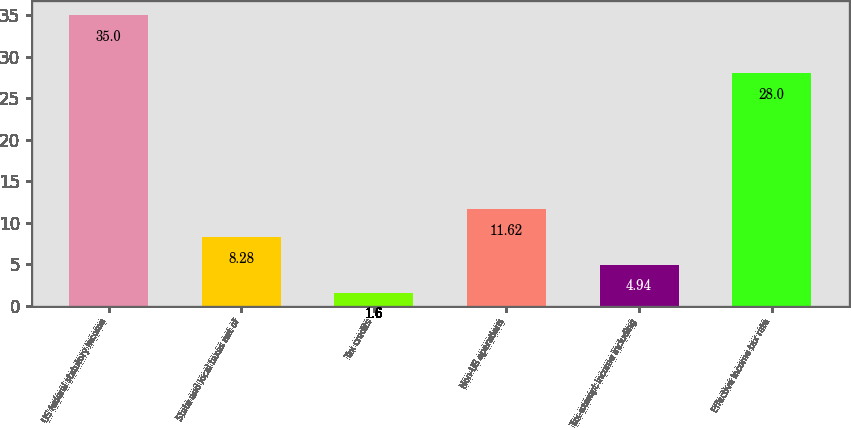Convert chart. <chart><loc_0><loc_0><loc_500><loc_500><bar_chart><fcel>US federal statutory income<fcel>State and local taxes net of<fcel>Tax credits<fcel>Non-US operations<fcel>Tax-exempt income including<fcel>Effective income tax rate<nl><fcel>35<fcel>8.28<fcel>1.6<fcel>11.62<fcel>4.94<fcel>28<nl></chart> 